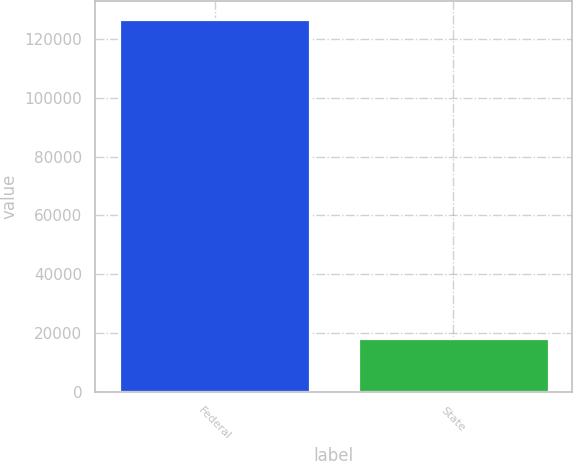Convert chart. <chart><loc_0><loc_0><loc_500><loc_500><bar_chart><fcel>Federal<fcel>State<nl><fcel>126726<fcel>18433<nl></chart> 